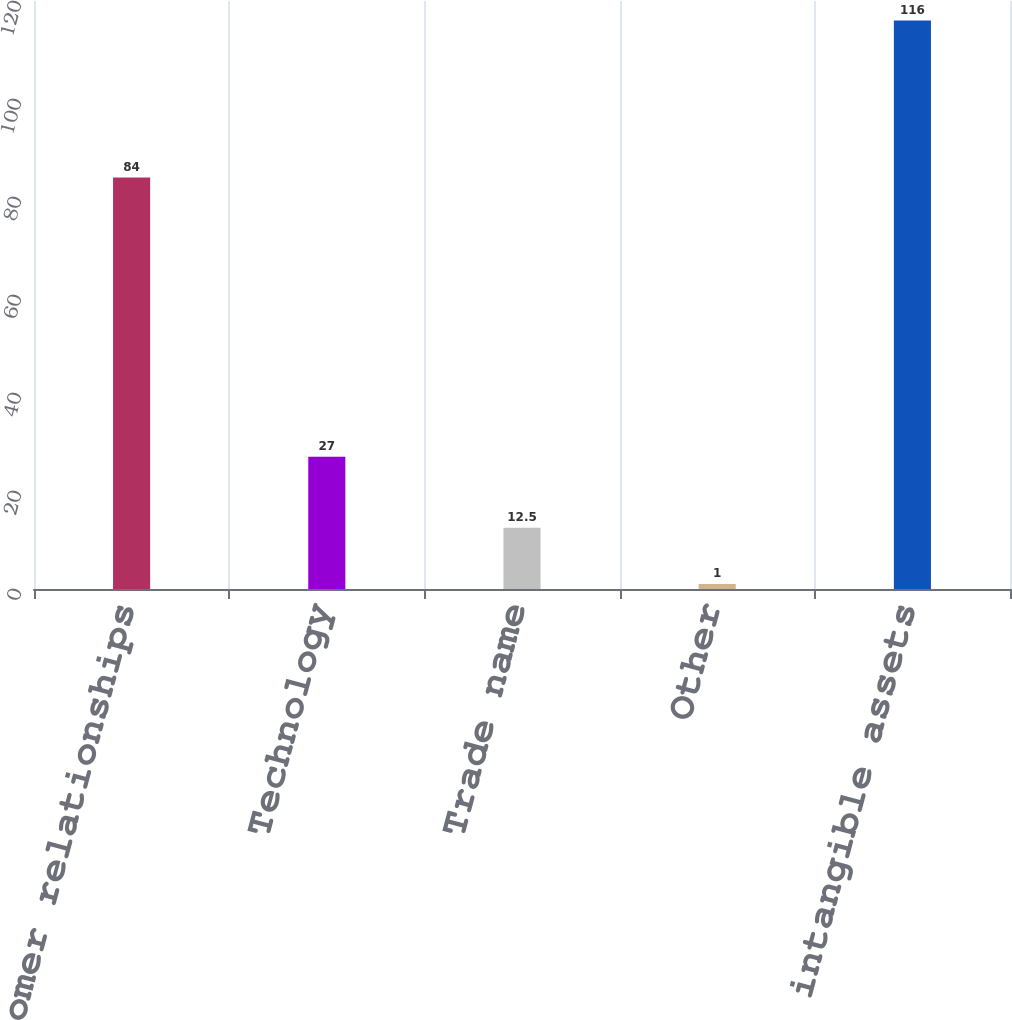Convert chart. <chart><loc_0><loc_0><loc_500><loc_500><bar_chart><fcel>Customer relationships<fcel>Technology<fcel>Trade name<fcel>Other<fcel>Total intangible assets<nl><fcel>84<fcel>27<fcel>12.5<fcel>1<fcel>116<nl></chart> 